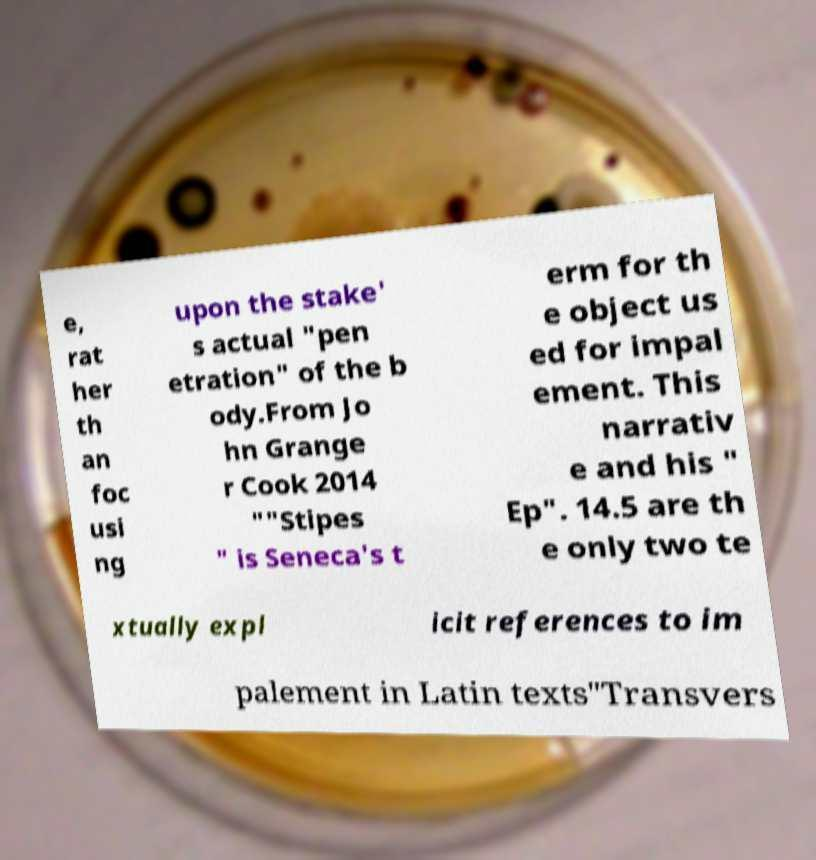Can you accurately transcribe the text from the provided image for me? e, rat her th an foc usi ng upon the stake' s actual "pen etration" of the b ody.From Jo hn Grange r Cook 2014 ""Stipes " is Seneca's t erm for th e object us ed for impal ement. This narrativ e and his " Ep". 14.5 are th e only two te xtually expl icit references to im palement in Latin texts"Transvers 